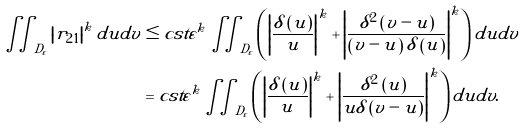Convert formula to latex. <formula><loc_0><loc_0><loc_500><loc_500>\iint _ { D _ { \varepsilon } } \left | r _ { 2 1 } \right | ^ { k } d u d v & \leq c s t \varepsilon ^ { k } \iint _ { D _ { \varepsilon } } \left ( \left | \frac { \delta \left ( u \right ) } { u } \right | ^ { k } + \left | \frac { \delta ^ { 2 } \left ( v - u \right ) } { \left ( v - u \right ) \delta \left ( u \right ) } \right | ^ { k } \right ) d u d v \\ & = c s t \varepsilon ^ { k } \iint _ { D _ { \varepsilon } } \left ( \left | \frac { \delta \left ( u \right ) } { u } \right | ^ { k } + \left | \frac { \delta ^ { 2 } \left ( u \right ) } { u \delta \left ( v - u \right ) } \right | ^ { k } \right ) d u d v .</formula> 